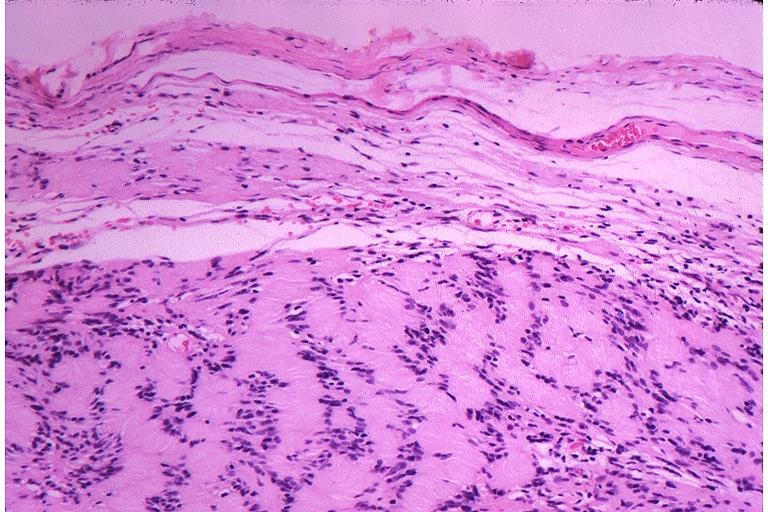s iron present?
Answer the question using a single word or phrase. No 